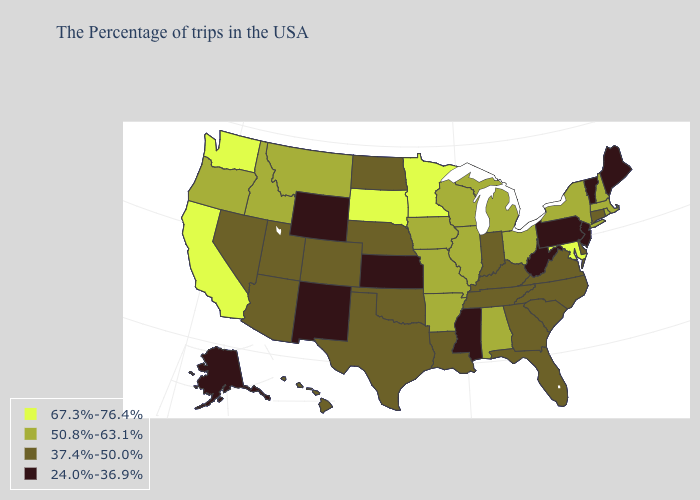What is the value of Oklahoma?
Answer briefly. 37.4%-50.0%. Which states have the lowest value in the USA?
Keep it brief. Maine, Vermont, New Jersey, Pennsylvania, West Virginia, Mississippi, Kansas, Wyoming, New Mexico, Alaska. What is the highest value in the West ?
Keep it brief. 67.3%-76.4%. What is the highest value in states that border Oregon?
Keep it brief. 67.3%-76.4%. What is the value of Arkansas?
Concise answer only. 50.8%-63.1%. What is the value of Kansas?
Quick response, please. 24.0%-36.9%. What is the lowest value in the USA?
Give a very brief answer. 24.0%-36.9%. Does Minnesota have the same value as Alaska?
Short answer required. No. Name the states that have a value in the range 37.4%-50.0%?
Give a very brief answer. Connecticut, Delaware, Virginia, North Carolina, South Carolina, Florida, Georgia, Kentucky, Indiana, Tennessee, Louisiana, Nebraska, Oklahoma, Texas, North Dakota, Colorado, Utah, Arizona, Nevada, Hawaii. How many symbols are there in the legend?
Keep it brief. 4. What is the value of Wyoming?
Write a very short answer. 24.0%-36.9%. Does New Hampshire have a higher value than Missouri?
Write a very short answer. No. Does New Jersey have the lowest value in the USA?
Keep it brief. Yes. What is the value of Ohio?
Answer briefly. 50.8%-63.1%. What is the value of Vermont?
Quick response, please. 24.0%-36.9%. 